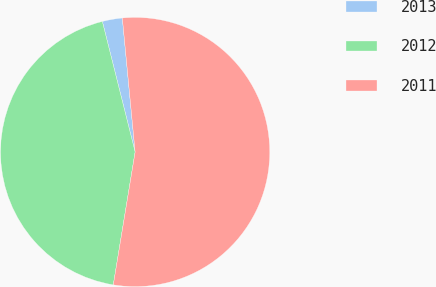Convert chart to OTSL. <chart><loc_0><loc_0><loc_500><loc_500><pie_chart><fcel>2013<fcel>2012<fcel>2011<nl><fcel>2.4%<fcel>43.49%<fcel>54.11%<nl></chart> 